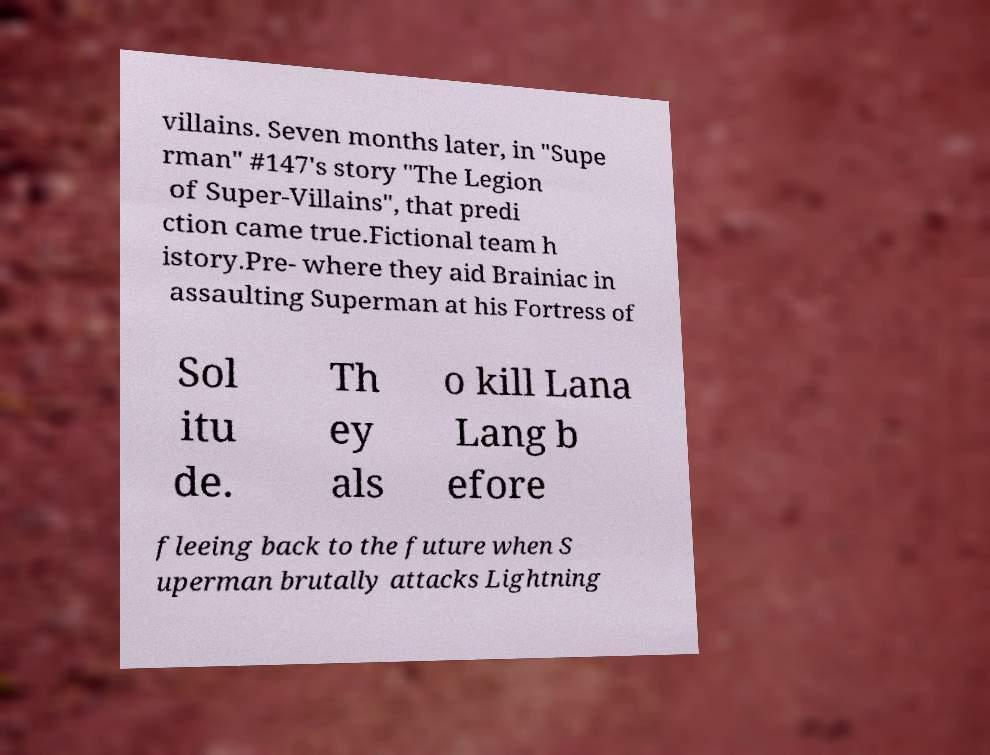Can you accurately transcribe the text from the provided image for me? villains. Seven months later, in "Supe rman" #147's story "The Legion of Super-Villains", that predi ction came true.Fictional team h istory.Pre- where they aid Brainiac in assaulting Superman at his Fortress of Sol itu de. Th ey als o kill Lana Lang b efore fleeing back to the future when S uperman brutally attacks Lightning 